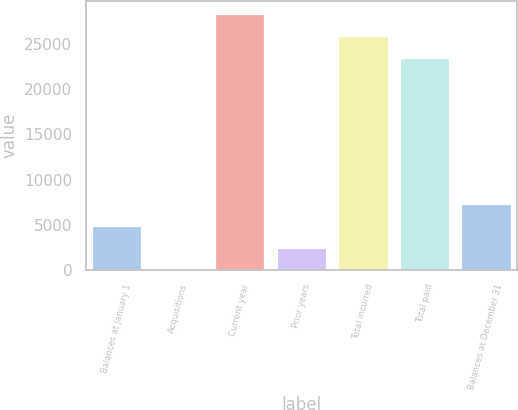Convert chart to OTSL. <chart><loc_0><loc_0><loc_500><loc_500><bar_chart><fcel>Balances at January 1<fcel>Acquisitions<fcel>Current year<fcel>Prior years<fcel>Total incurred<fcel>Total paid<fcel>Balances at December 31<nl><fcel>4845.46<fcel>0.32<fcel>28366.1<fcel>2422.89<fcel>25943.6<fcel>23521<fcel>7268.03<nl></chart> 